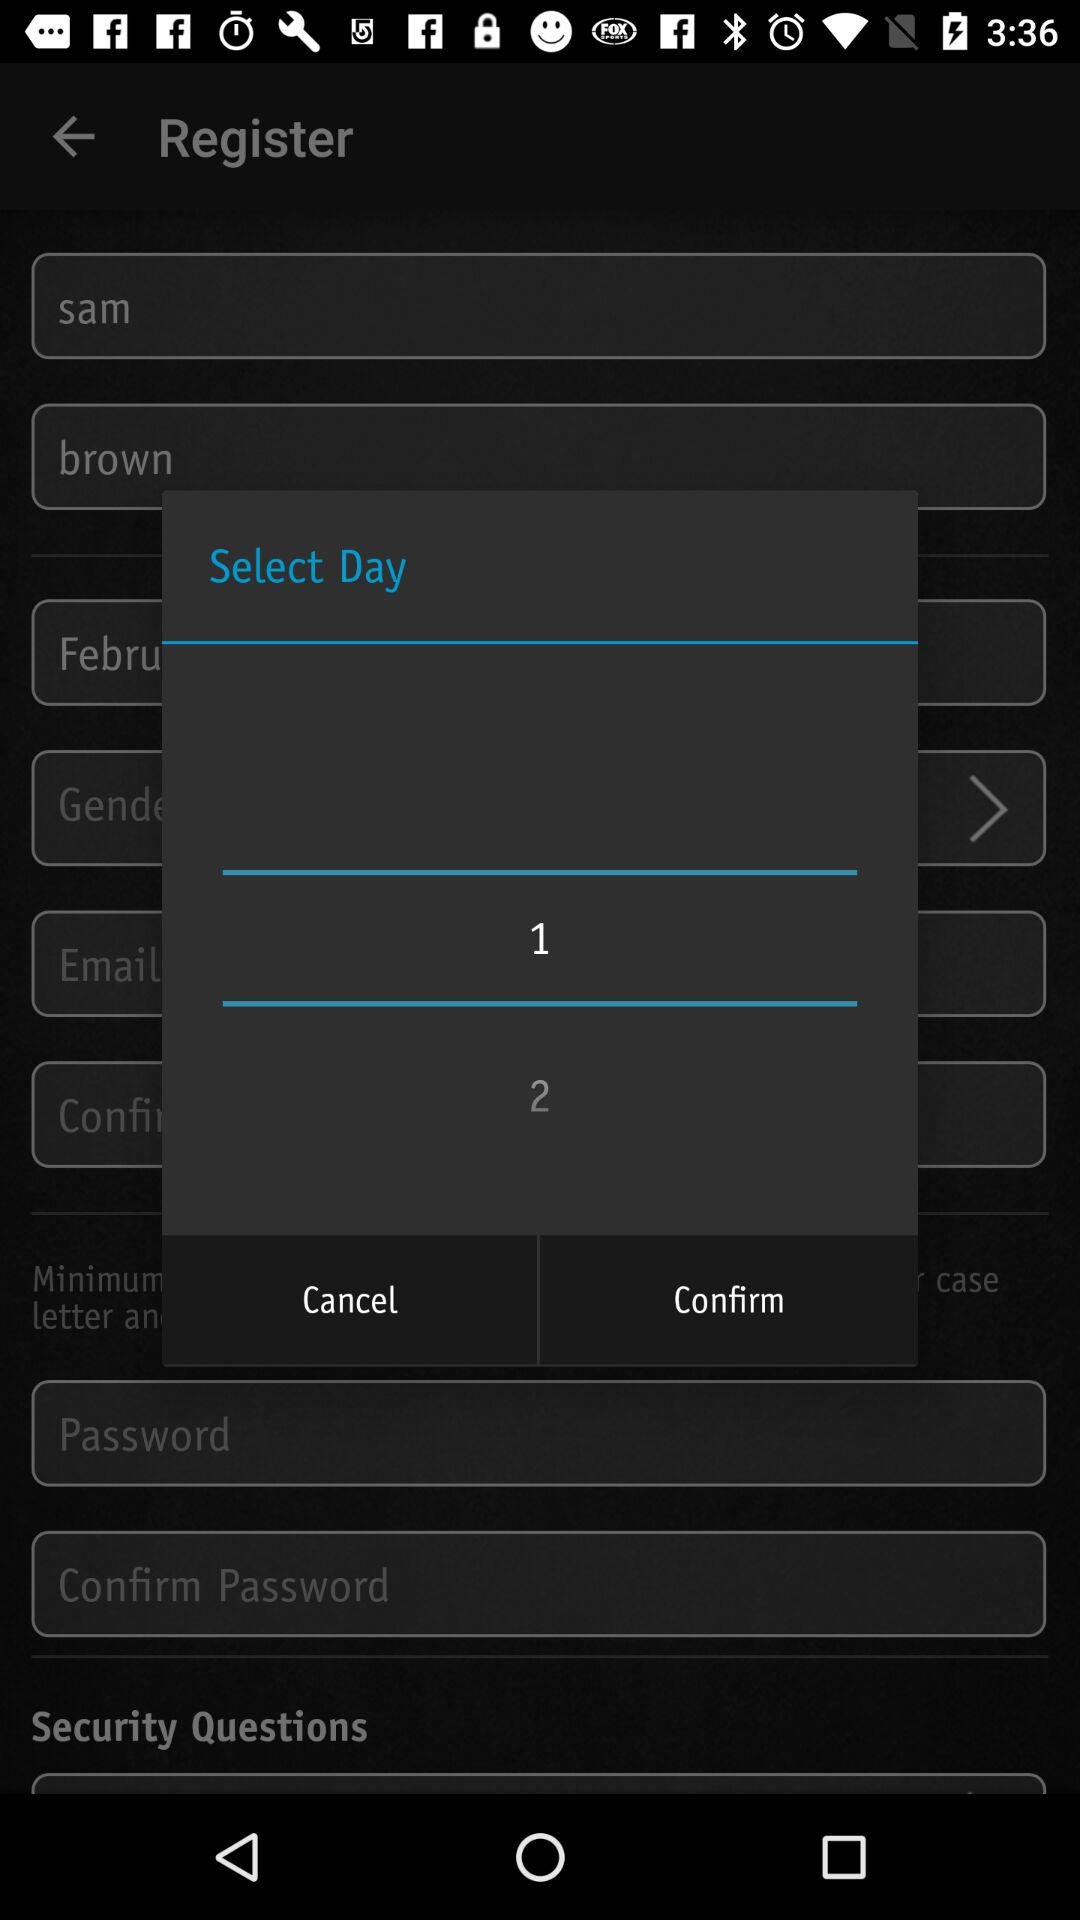Which gender did the user select?
When the provided information is insufficient, respond with <no answer>. <no answer> 